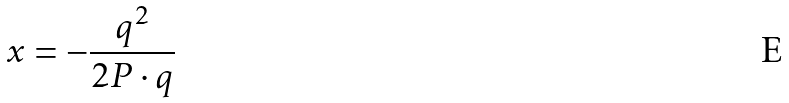Convert formula to latex. <formula><loc_0><loc_0><loc_500><loc_500>x = - \frac { q ^ { 2 } } { 2 P \cdot q }</formula> 